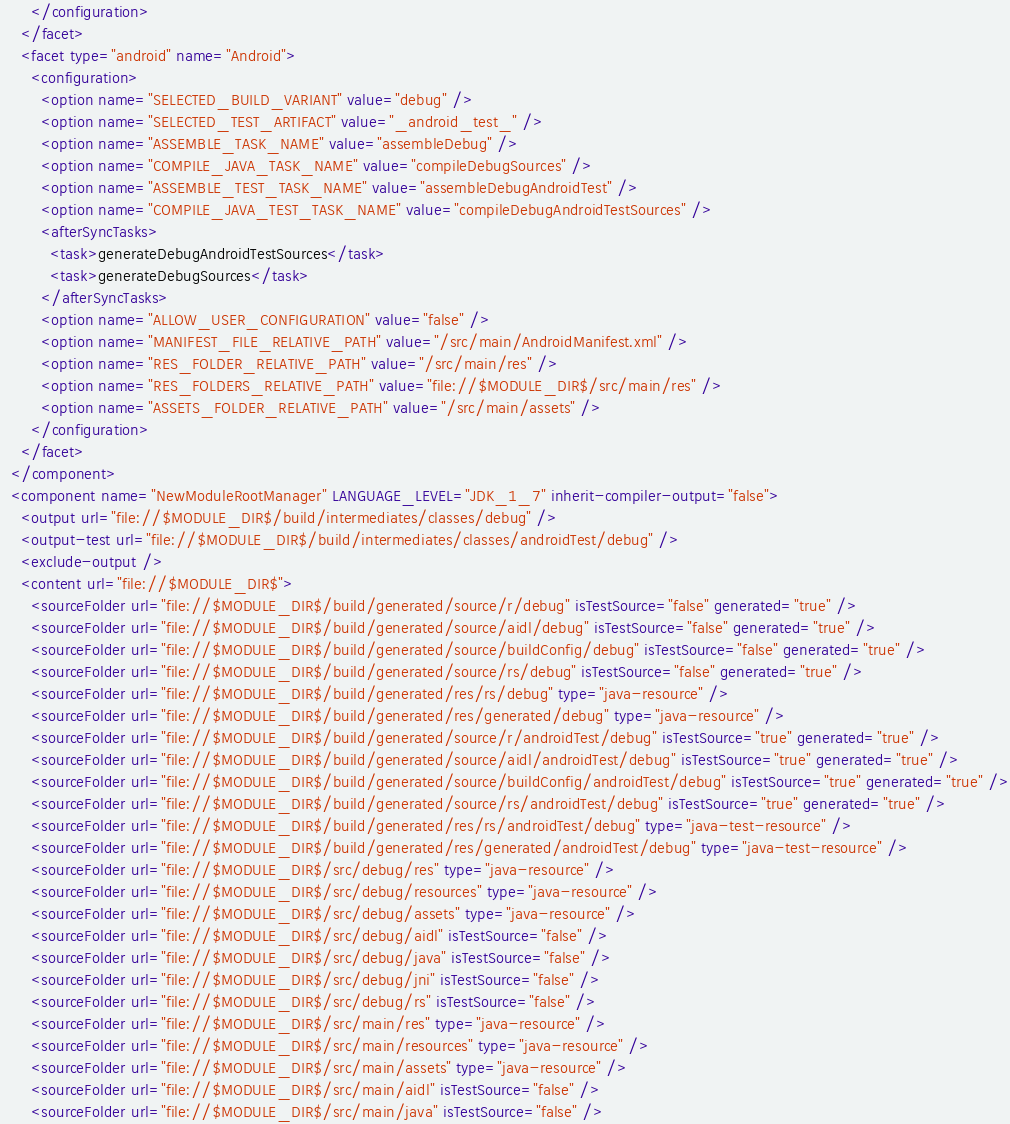Convert code to text. <code><loc_0><loc_0><loc_500><loc_500><_XML_>      </configuration>
    </facet>
    <facet type="android" name="Android">
      <configuration>
        <option name="SELECTED_BUILD_VARIANT" value="debug" />
        <option name="SELECTED_TEST_ARTIFACT" value="_android_test_" />
        <option name="ASSEMBLE_TASK_NAME" value="assembleDebug" />
        <option name="COMPILE_JAVA_TASK_NAME" value="compileDebugSources" />
        <option name="ASSEMBLE_TEST_TASK_NAME" value="assembleDebugAndroidTest" />
        <option name="COMPILE_JAVA_TEST_TASK_NAME" value="compileDebugAndroidTestSources" />
        <afterSyncTasks>
          <task>generateDebugAndroidTestSources</task>
          <task>generateDebugSources</task>
        </afterSyncTasks>
        <option name="ALLOW_USER_CONFIGURATION" value="false" />
        <option name="MANIFEST_FILE_RELATIVE_PATH" value="/src/main/AndroidManifest.xml" />
        <option name="RES_FOLDER_RELATIVE_PATH" value="/src/main/res" />
        <option name="RES_FOLDERS_RELATIVE_PATH" value="file://$MODULE_DIR$/src/main/res" />
        <option name="ASSETS_FOLDER_RELATIVE_PATH" value="/src/main/assets" />
      </configuration>
    </facet>
  </component>
  <component name="NewModuleRootManager" LANGUAGE_LEVEL="JDK_1_7" inherit-compiler-output="false">
    <output url="file://$MODULE_DIR$/build/intermediates/classes/debug" />
    <output-test url="file://$MODULE_DIR$/build/intermediates/classes/androidTest/debug" />
    <exclude-output />
    <content url="file://$MODULE_DIR$">
      <sourceFolder url="file://$MODULE_DIR$/build/generated/source/r/debug" isTestSource="false" generated="true" />
      <sourceFolder url="file://$MODULE_DIR$/build/generated/source/aidl/debug" isTestSource="false" generated="true" />
      <sourceFolder url="file://$MODULE_DIR$/build/generated/source/buildConfig/debug" isTestSource="false" generated="true" />
      <sourceFolder url="file://$MODULE_DIR$/build/generated/source/rs/debug" isTestSource="false" generated="true" />
      <sourceFolder url="file://$MODULE_DIR$/build/generated/res/rs/debug" type="java-resource" />
      <sourceFolder url="file://$MODULE_DIR$/build/generated/res/generated/debug" type="java-resource" />
      <sourceFolder url="file://$MODULE_DIR$/build/generated/source/r/androidTest/debug" isTestSource="true" generated="true" />
      <sourceFolder url="file://$MODULE_DIR$/build/generated/source/aidl/androidTest/debug" isTestSource="true" generated="true" />
      <sourceFolder url="file://$MODULE_DIR$/build/generated/source/buildConfig/androidTest/debug" isTestSource="true" generated="true" />
      <sourceFolder url="file://$MODULE_DIR$/build/generated/source/rs/androidTest/debug" isTestSource="true" generated="true" />
      <sourceFolder url="file://$MODULE_DIR$/build/generated/res/rs/androidTest/debug" type="java-test-resource" />
      <sourceFolder url="file://$MODULE_DIR$/build/generated/res/generated/androidTest/debug" type="java-test-resource" />
      <sourceFolder url="file://$MODULE_DIR$/src/debug/res" type="java-resource" />
      <sourceFolder url="file://$MODULE_DIR$/src/debug/resources" type="java-resource" />
      <sourceFolder url="file://$MODULE_DIR$/src/debug/assets" type="java-resource" />
      <sourceFolder url="file://$MODULE_DIR$/src/debug/aidl" isTestSource="false" />
      <sourceFolder url="file://$MODULE_DIR$/src/debug/java" isTestSource="false" />
      <sourceFolder url="file://$MODULE_DIR$/src/debug/jni" isTestSource="false" />
      <sourceFolder url="file://$MODULE_DIR$/src/debug/rs" isTestSource="false" />
      <sourceFolder url="file://$MODULE_DIR$/src/main/res" type="java-resource" />
      <sourceFolder url="file://$MODULE_DIR$/src/main/resources" type="java-resource" />
      <sourceFolder url="file://$MODULE_DIR$/src/main/assets" type="java-resource" />
      <sourceFolder url="file://$MODULE_DIR$/src/main/aidl" isTestSource="false" />
      <sourceFolder url="file://$MODULE_DIR$/src/main/java" isTestSource="false" /></code> 